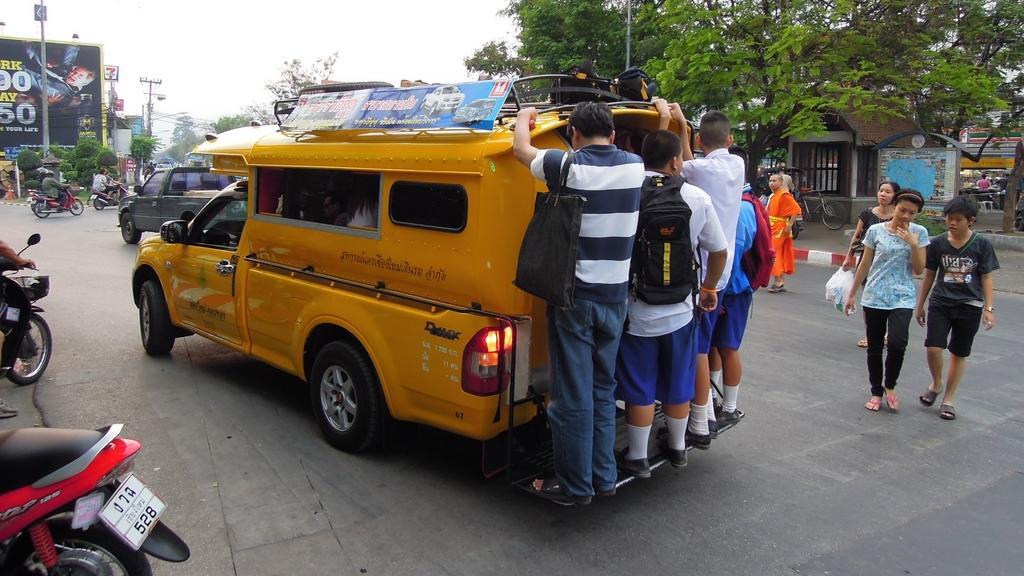Describe this image in one or two sentences. In this image, there is a road which is in black color, there is a car which is in yellow color, on that car there are some people standing and holding the car, in the background there are some people walking and there is a green color tree, in the left side there are some bikes. 